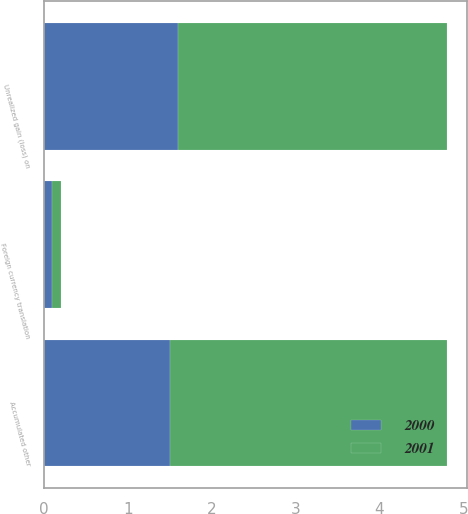<chart> <loc_0><loc_0><loc_500><loc_500><stacked_bar_chart><ecel><fcel>Foreign currency translation<fcel>Unrealized gain (loss) on<fcel>Accumulated other<nl><fcel>2001<fcel>0.1<fcel>3.2<fcel>3.3<nl><fcel>2000<fcel>0.1<fcel>1.6<fcel>1.5<nl></chart> 